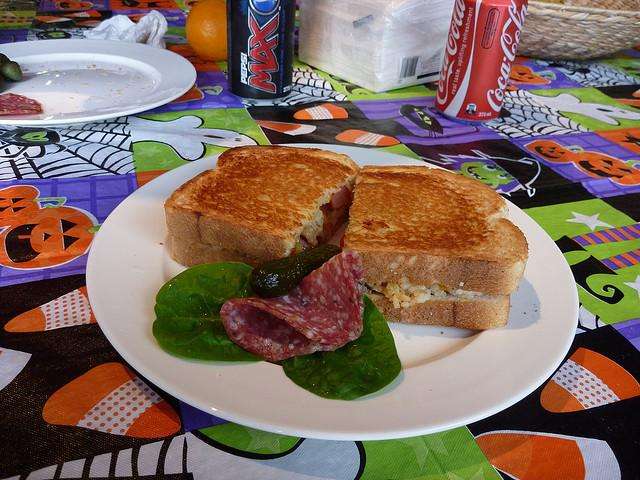What is the side dish? Please explain your reasoning. pickle. There is a pickle. 